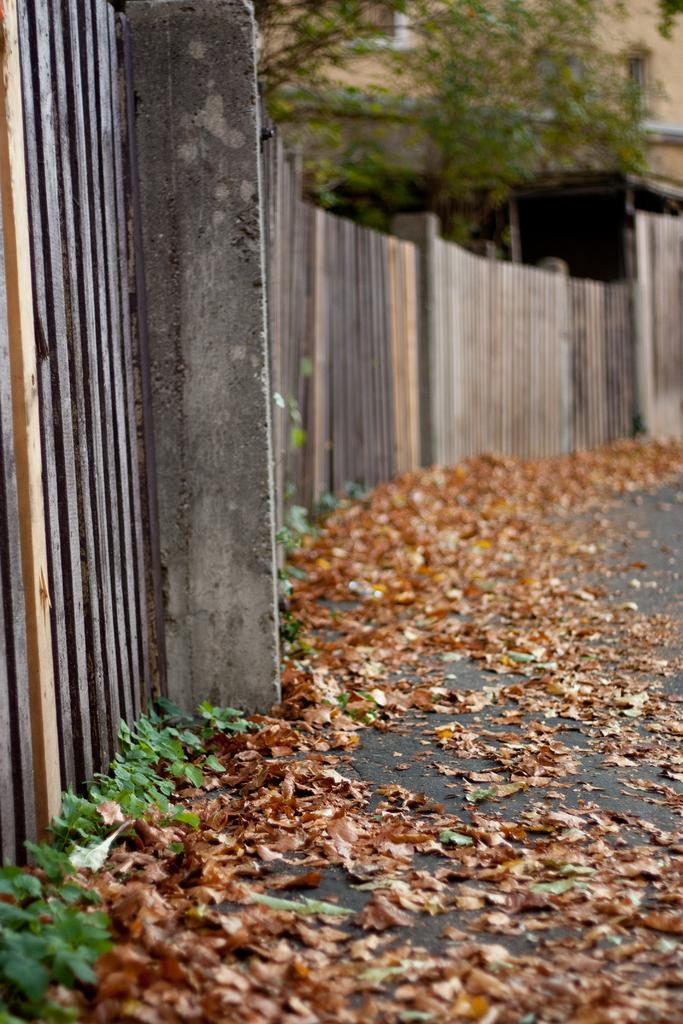What type of fencing is visible in the image? There is a wooden fencing in the image. How is the wooden fencing described in the image? The wooden fencing appears to be truncated. What other natural element is present in the image? There is a tree in the image. How is the tree described in the image? The tree appears to be truncated. What can be found on the ground in the image? There are dried leaves on the ground in the image. What type of vegetation is present in the image? There are plants in the image. What type of ear is visible on the tree in the image? There is no ear present on the tree in the image; it is a tree with no visible ears. How low is the wooden fencing in the image? The wooden fencing is not described in terms of height or low in the image, only that it appears to be truncated. 